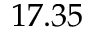Convert formula to latex. <formula><loc_0><loc_0><loc_500><loc_500>1 7 . 3 5</formula> 